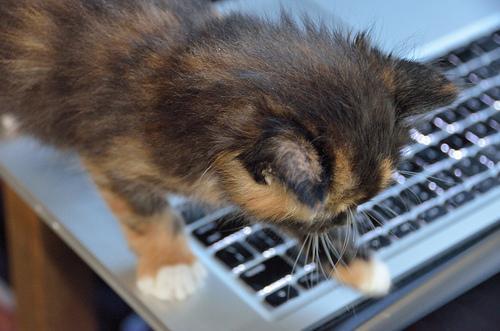How many kittens are in the picture?
Give a very brief answer. 1. 